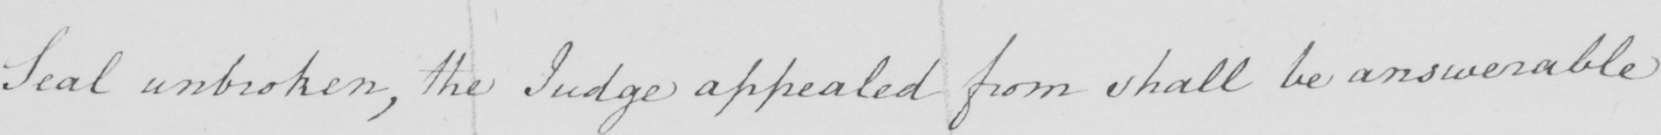What is written in this line of handwriting? Seal unbroken , the Judge appealed from shall be answerable 